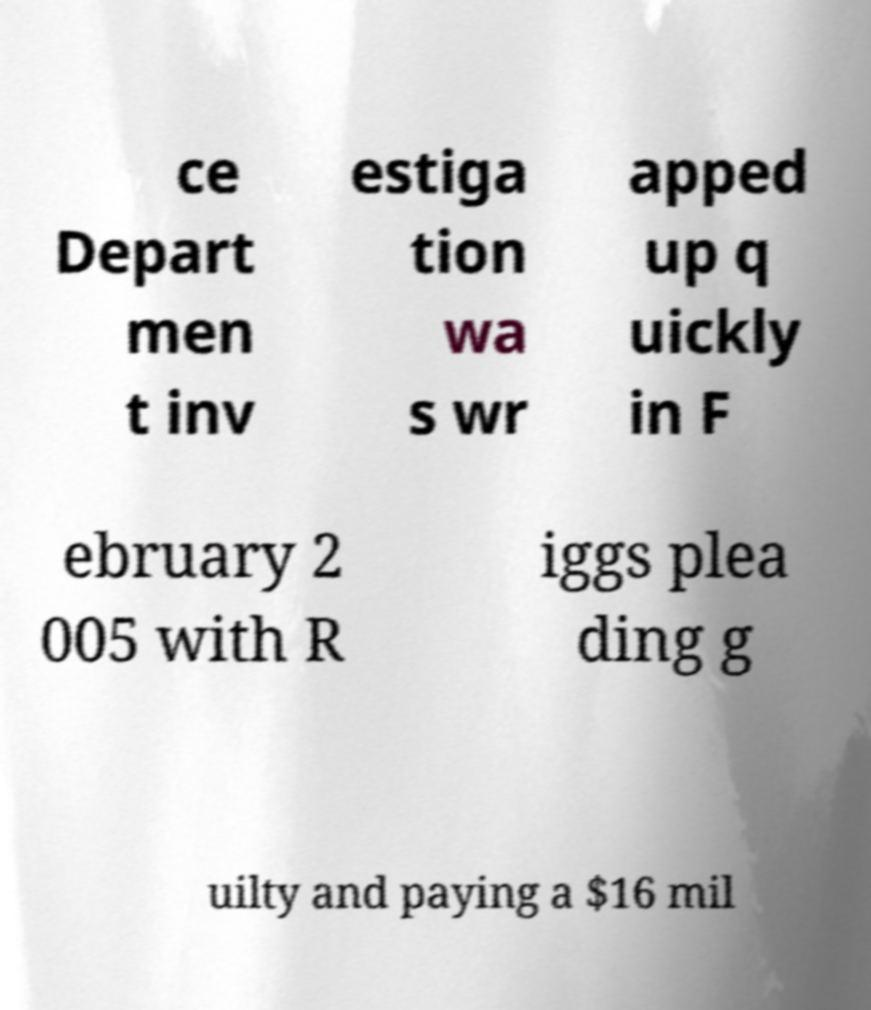Please read and relay the text visible in this image. What does it say? ce Depart men t inv estiga tion wa s wr apped up q uickly in F ebruary 2 005 with R iggs plea ding g uilty and paying a $16 mil 